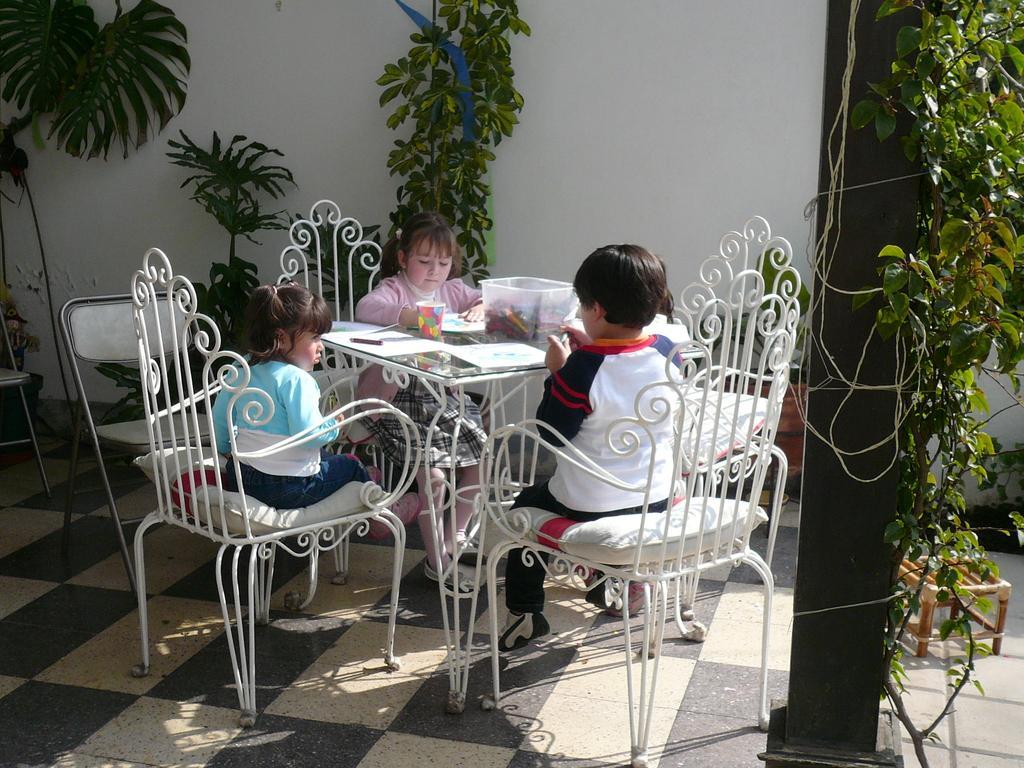How would you summarize this image in a sentence or two? In this picture we can see three children sitting on chair and in front of them there is table and on table we can see glass, paper, pen, box with crayons in it and in background we can see tree, wall, stool. 